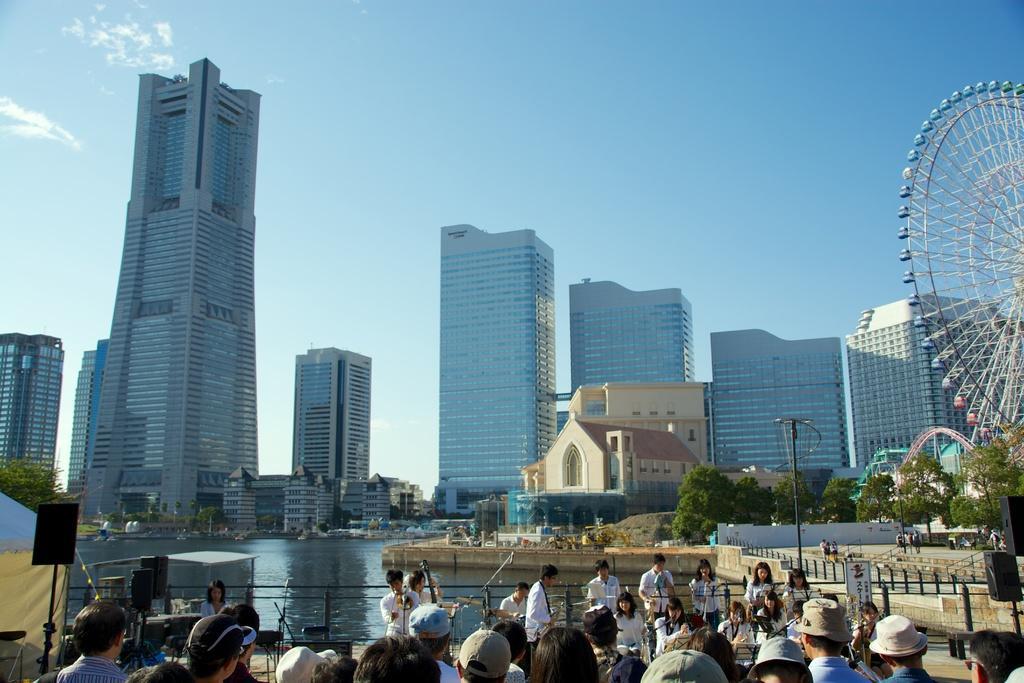Could you give a brief overview of what you see in this image? In this image we can see a few people, among them some people are sitting and some people are standing, we can see some people holding the objects, there are some trees, poles, buildings, water, fence, giant wheels and some other objects, in the background we can see the sky. 